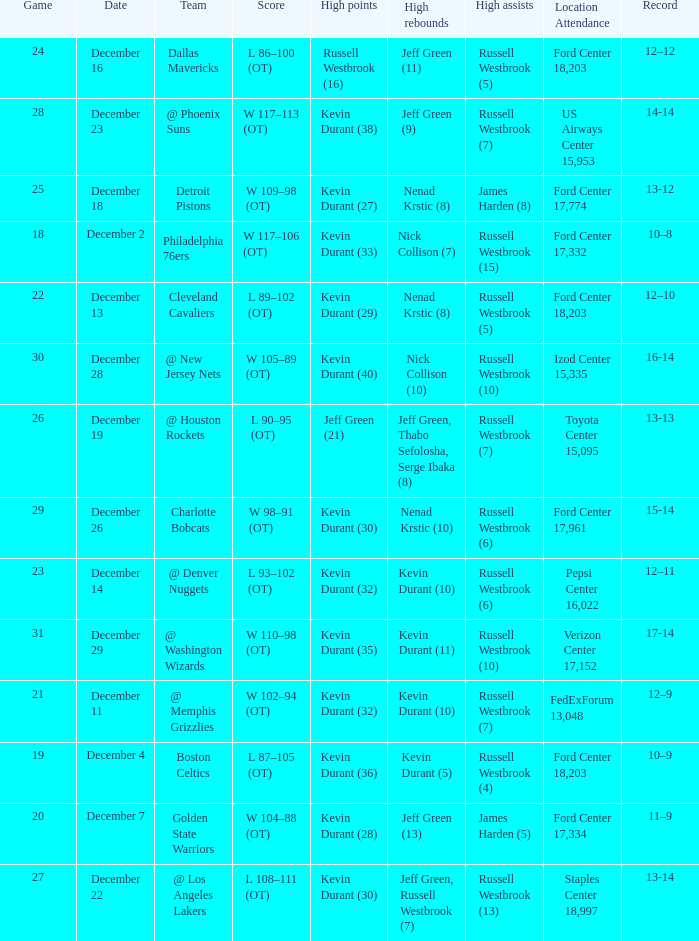What location attendance has russell westbrook (5) as high assists and nenad krstic (8) as high rebounds? Ford Center 18,203. 